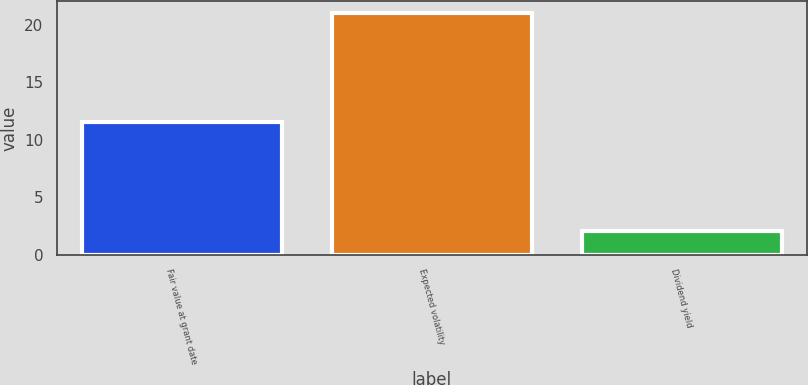<chart> <loc_0><loc_0><loc_500><loc_500><bar_chart><fcel>Fair value at grant date<fcel>Expected volatility<fcel>Dividend yield<nl><fcel>11.57<fcel>21<fcel>2.1<nl></chart> 